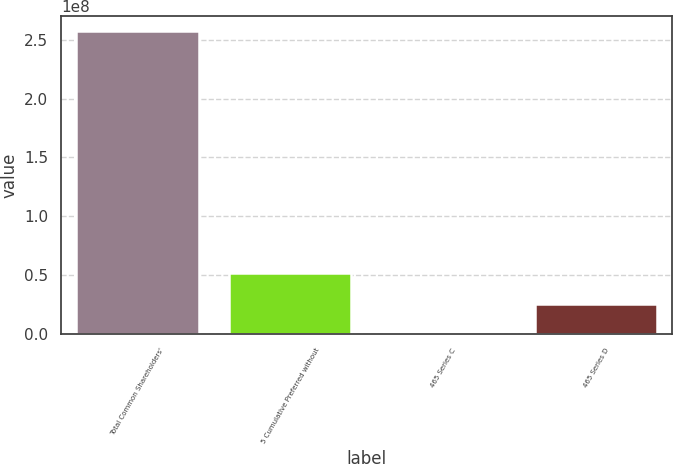Convert chart to OTSL. <chart><loc_0><loc_0><loc_500><loc_500><bar_chart><fcel>Total Common Shareholders'<fcel>5 Cumulative Preferred without<fcel>465 Series C<fcel>465 Series D<nl><fcel>2.57456e+08<fcel>5.16139e+07<fcel>153296<fcel>2.58836e+07<nl></chart> 